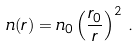Convert formula to latex. <formula><loc_0><loc_0><loc_500><loc_500>n ( r ) = n _ { 0 } \left ( \frac { r _ { 0 } } { r } \right ) ^ { 2 } \, .</formula> 